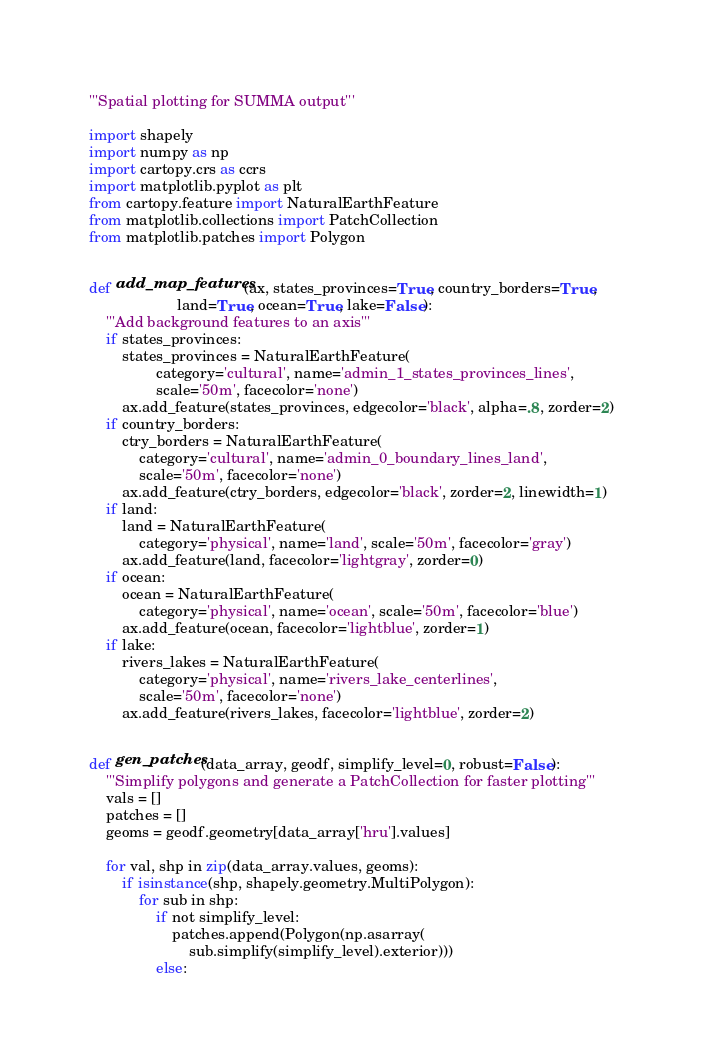<code> <loc_0><loc_0><loc_500><loc_500><_Python_>'''Spatial plotting for SUMMA output'''

import shapely
import numpy as np
import cartopy.crs as ccrs
import matplotlib.pyplot as plt
from cartopy.feature import NaturalEarthFeature
from matplotlib.collections import PatchCollection
from matplotlib.patches import Polygon


def add_map_features(ax, states_provinces=True, country_borders=True,
                     land=True, ocean=True, lake=False):
    '''Add background features to an axis'''
    if states_provinces:
        states_provinces = NaturalEarthFeature(
                category='cultural', name='admin_1_states_provinces_lines',
                scale='50m', facecolor='none')
        ax.add_feature(states_provinces, edgecolor='black', alpha=.8, zorder=2)
    if country_borders:
        ctry_borders = NaturalEarthFeature(
            category='cultural', name='admin_0_boundary_lines_land',
            scale='50m', facecolor='none')
        ax.add_feature(ctry_borders, edgecolor='black', zorder=2, linewidth=1)
    if land:
        land = NaturalEarthFeature(
            category='physical', name='land', scale='50m', facecolor='gray')
        ax.add_feature(land, facecolor='lightgray', zorder=0)
    if ocean:
        ocean = NaturalEarthFeature(
            category='physical', name='ocean', scale='50m', facecolor='blue')
        ax.add_feature(ocean, facecolor='lightblue', zorder=1)
    if lake:
        rivers_lakes = NaturalEarthFeature(
            category='physical', name='rivers_lake_centerlines',
            scale='50m', facecolor='none')
        ax.add_feature(rivers_lakes, facecolor='lightblue', zorder=2)


def gen_patches(data_array, geodf, simplify_level=0, robust=False):
    '''Simplify polygons and generate a PatchCollection for faster plotting'''
    vals = []
    patches = []
    geoms = geodf.geometry[data_array['hru'].values]

    for val, shp in zip(data_array.values, geoms):
        if isinstance(shp, shapely.geometry.MultiPolygon):
            for sub in shp:
                if not simplify_level:
                    patches.append(Polygon(np.asarray(
                        sub.simplify(simplify_level).exterior)))
                else:</code> 